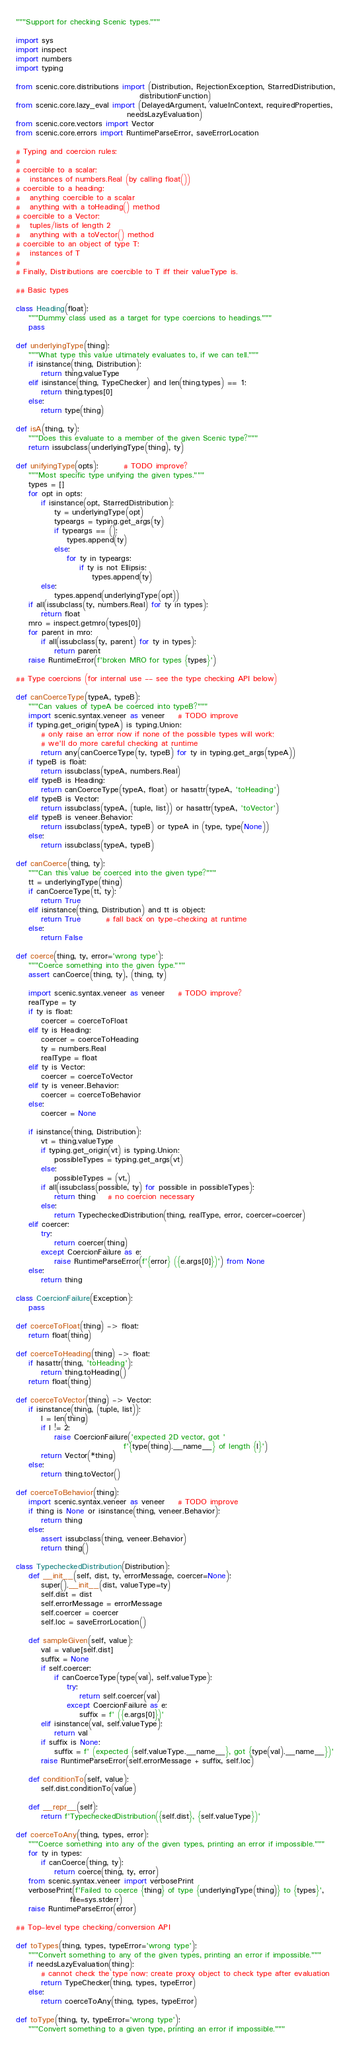<code> <loc_0><loc_0><loc_500><loc_500><_Python_>"""Support for checking Scenic types."""

import sys
import inspect
import numbers
import typing

from scenic.core.distributions import (Distribution, RejectionException, StarredDistribution,
                                       distributionFunction)
from scenic.core.lazy_eval import (DelayedArgument, valueInContext, requiredProperties,
                                   needsLazyEvaluation)
from scenic.core.vectors import Vector
from scenic.core.errors import RuntimeParseError, saveErrorLocation

# Typing and coercion rules:
#
# coercible to a scalar:
#   instances of numbers.Real (by calling float())
# coercible to a heading:
#	anything coercible to a scalar
#	anything with a toHeading() method
# coercible to a Vector:
#   tuples/lists of length 2
#   anything with a toVector() method
# coercible to an object of type T:
#   instances of T
#
# Finally, Distributions are coercible to T iff their valueType is.

## Basic types

class Heading(float):
	"""Dummy class used as a target for type coercions to headings."""
	pass

def underlyingType(thing):
	"""What type this value ultimately evaluates to, if we can tell."""
	if isinstance(thing, Distribution):
		return thing.valueType
	elif isinstance(thing, TypeChecker) and len(thing.types) == 1:
		return thing.types[0]
	else:
		return type(thing)

def isA(thing, ty):
	"""Does this evaluate to a member of the given Scenic type?"""
	return issubclass(underlyingType(thing), ty)

def unifyingType(opts):		# TODO improve?
	"""Most specific type unifying the given types."""
	types = []
	for opt in opts:
		if isinstance(opt, StarredDistribution):
			ty = underlyingType(opt)
			typeargs = typing.get_args(ty)
			if typeargs == ():
				types.append(ty)
			else:
				for ty in typeargs:
					if ty is not Ellipsis:
						types.append(ty)
		else:
			types.append(underlyingType(opt))
	if all(issubclass(ty, numbers.Real) for ty in types):
		return float
	mro = inspect.getmro(types[0])
	for parent in mro:
		if all(issubclass(ty, parent) for ty in types):
			return parent
	raise RuntimeError(f'broken MRO for types {types}')

## Type coercions (for internal use -- see the type checking API below)

def canCoerceType(typeA, typeB):
	"""Can values of typeA be coerced into typeB?"""
	import scenic.syntax.veneer as veneer	# TODO improve
	if typing.get_origin(typeA) is typing.Union:
		# only raise an error now if none of the possible types will work;
		# we'll do more careful checking at runtime
		return any(canCoerceType(ty, typeB) for ty in typing.get_args(typeA))
	if typeB is float:
		return issubclass(typeA, numbers.Real)
	elif typeB is Heading:
		return canCoerceType(typeA, float) or hasattr(typeA, 'toHeading')
	elif typeB is Vector:
		return issubclass(typeA, (tuple, list)) or hasattr(typeA, 'toVector')
	elif typeB is veneer.Behavior:
		return issubclass(typeA, typeB) or typeA in (type, type(None))
	else:
		return issubclass(typeA, typeB)

def canCoerce(thing, ty):
	"""Can this value be coerced into the given type?"""
	tt = underlyingType(thing)
	if canCoerceType(tt, ty):
		return True
	elif isinstance(thing, Distribution) and tt is object:
		return True		# fall back on type-checking at runtime
	else:
		return False

def coerce(thing, ty, error='wrong type'):
	"""Coerce something into the given type."""
	assert canCoerce(thing, ty), (thing, ty)

	import scenic.syntax.veneer as veneer	# TODO improve?
	realType = ty
	if ty is float:
		coercer = coerceToFloat
	elif ty is Heading:
		coercer = coerceToHeading
		ty = numbers.Real
		realType = float
	elif ty is Vector:
		coercer = coerceToVector
	elif ty is veneer.Behavior:
		coercer = coerceToBehavior
	else:
		coercer = None

	if isinstance(thing, Distribution):
		vt = thing.valueType
		if typing.get_origin(vt) is typing.Union:
			possibleTypes = typing.get_args(vt)
		else:
			possibleTypes = (vt,)
		if all(issubclass(possible, ty) for possible in possibleTypes):
			return thing 	# no coercion necessary
		else:
			return TypecheckedDistribution(thing, realType, error, coercer=coercer)
	elif coercer:
		try:
			return coercer(thing)
		except CoercionFailure as e:
			raise RuntimeParseError(f'{error} ({e.args[0]})') from None
	else:
		return thing

class CoercionFailure(Exception):
	pass

def coerceToFloat(thing) -> float:
	return float(thing)

def coerceToHeading(thing) -> float:
	if hasattr(thing, 'toHeading'):
		return thing.toHeading()
	return float(thing)

def coerceToVector(thing) -> Vector:
	if isinstance(thing, (tuple, list)):
		l = len(thing)
		if l != 2:
			raise CoercionFailure('expected 2D vector, got '
			                      f'{type(thing).__name__} of length {l}')
		return Vector(*thing)
	else:
		return thing.toVector()

def coerceToBehavior(thing):
	import scenic.syntax.veneer as veneer	# TODO improve
	if thing is None or isinstance(thing, veneer.Behavior):
		return thing
	else:
		assert issubclass(thing, veneer.Behavior)
		return thing()

class TypecheckedDistribution(Distribution):
	def __init__(self, dist, ty, errorMessage, coercer=None):
		super().__init__(dist, valueType=ty)
		self.dist = dist
		self.errorMessage = errorMessage
		self.coercer = coercer
		self.loc = saveErrorLocation()

	def sampleGiven(self, value):
		val = value[self.dist]
		suffix = None
		if self.coercer:
			if canCoerceType(type(val), self.valueType):
				try:
					return self.coercer(val)
				except CoercionFailure as e:
					suffix = f' ({e.args[0]})'
		elif isinstance(val, self.valueType):
			return val
		if suffix is None:
			suffix = f' (expected {self.valueType.__name__}, got {type(val).__name__})'
		raise RuntimeParseError(self.errorMessage + suffix, self.loc)

	def conditionTo(self, value):
		self.dist.conditionTo(value)

	def __repr__(self):
		return f'TypecheckedDistribution({self.dist}, {self.valueType})'

def coerceToAny(thing, types, error):
	"""Coerce something into any of the given types, printing an error if impossible."""
	for ty in types:
		if canCoerce(thing, ty):
			return coerce(thing, ty, error)
	from scenic.syntax.veneer import verbosePrint
	verbosePrint(f'Failed to coerce {thing} of type {underlyingType(thing)} to {types}',
	             file=sys.stderr)
	raise RuntimeParseError(error)

## Top-level type checking/conversion API

def toTypes(thing, types, typeError='wrong type'):
	"""Convert something to any of the given types, printing an error if impossible."""
	if needsLazyEvaluation(thing):
		# cannot check the type now; create proxy object to check type after evaluation
		return TypeChecker(thing, types, typeError)
	else:
		return coerceToAny(thing, types, typeError)

def toType(thing, ty, typeError='wrong type'):
	"""Convert something to a given type, printing an error if impossible."""</code> 